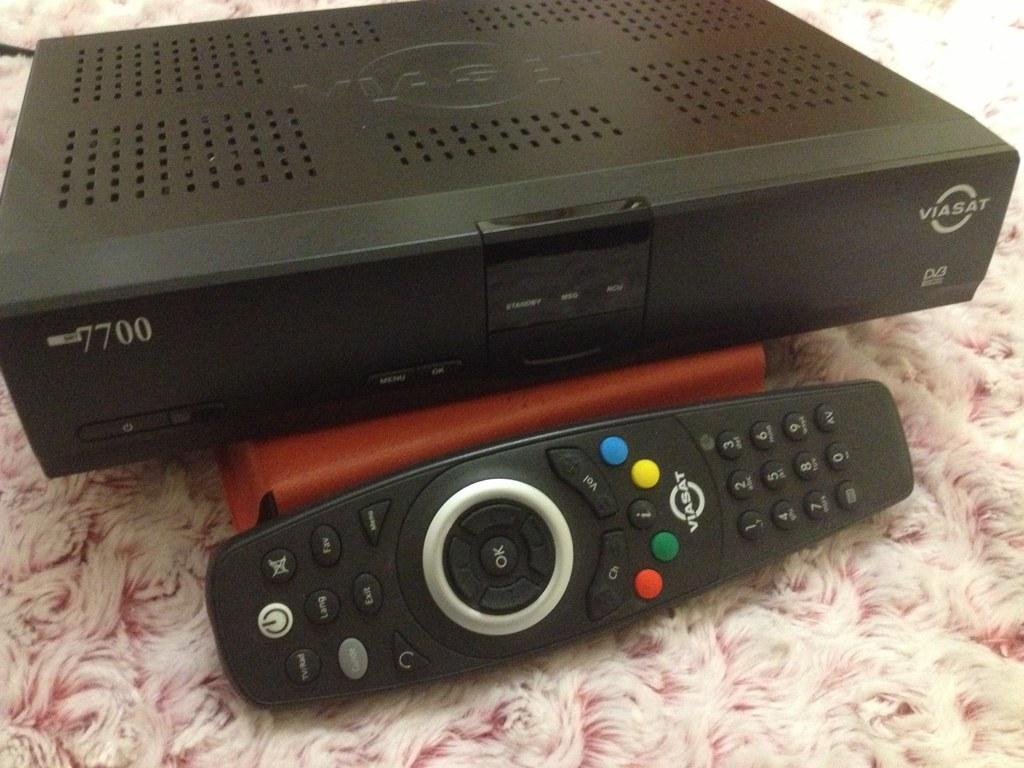Provide a one-sentence caption for the provided image. A dvr cable box and remote that goes with it on a pink shag carpet. 